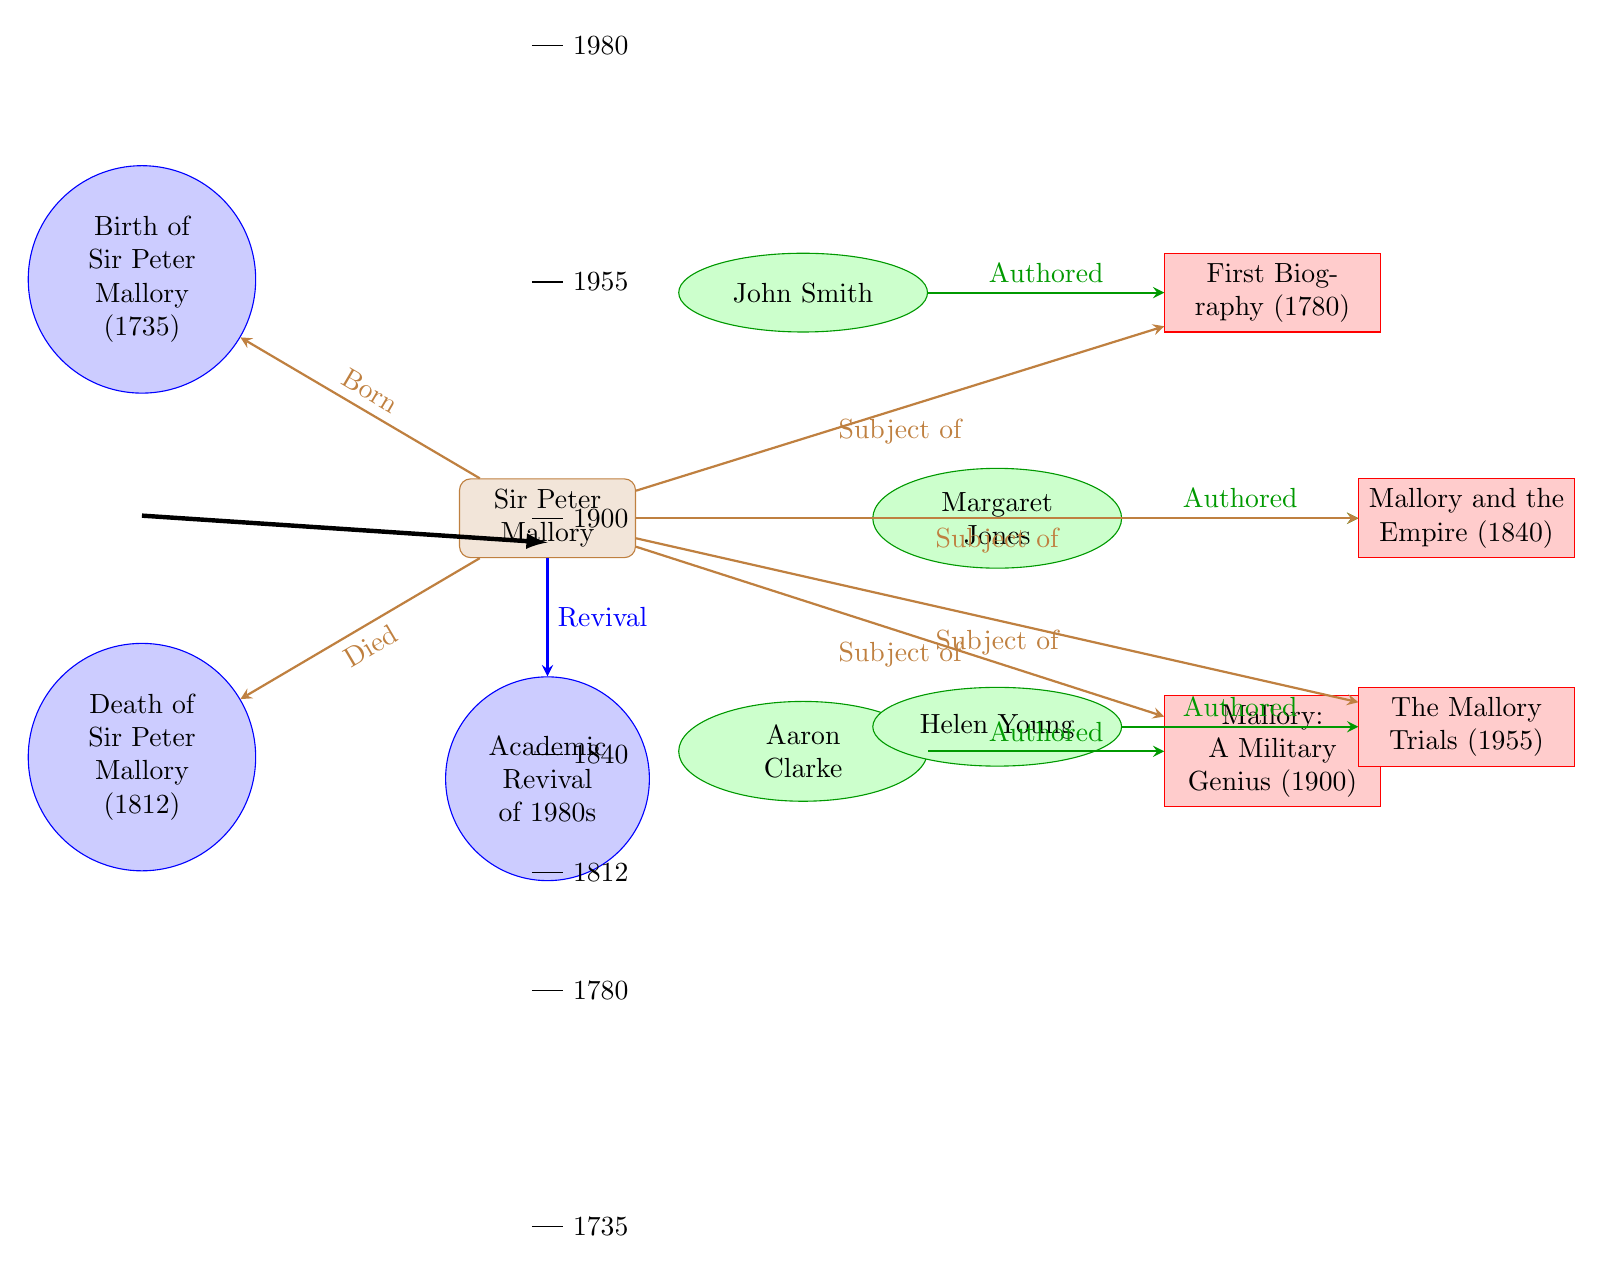What year was Sir Peter Mallory born? The diagram states that Sir Peter Mallory was born in 1735, which is indicated close to the node labeled "Birth of Sir Peter Mallory."
Answer: 1735 What event marks the death of Sir Peter Mallory? The node labeled "Death of Sir Peter Mallory (1812)" specifies the event that marks his death, which happened in 1812.
Answer: 1812 Who authored the first biography of Sir Peter Mallory? The diagram shows a connection from John Smith to the publication "First Biography (1780)," indicating that John Smith was the author of this biography.
Answer: John Smith Which publication discusses Mallory's military prowess? The publication labeled "Mallory: A Military Genius (1900)" is connected to Aaron Clarke, signifying that this work discusses Mallory's military contributions.
Answer: Mallory: A Military Genius (1900) What significant event occurred in the 1980s regarding Sir Peter Mallory? The diagram notes an "Academic Revival of 1980s," connected to Mallory, indicating that this was a significant event related to his legacy.
Answer: Academic Revival of 1980s Which publication occurred the earliest in the timeline? By examining the years associated with each publication in the timeline, the earliest publication is the "First Biography (1780)," which corresponds to 1780.
Answer: First Biography (1780) How many authors are mentioned in connection with Sir Peter Mallory? The diagram features four authors: John Smith, Margaret Jones, Aaron Clarke, and Helen Young, indicating a total count of four authors.
Answer: 4 What publication relates to the trials of Sir Peter Mallory? The publication titled "The Mallory Trials (1955)" is referenced in the diagram under Helen Young, indicating that it relates to the trials associated with Mallory.
Answer: The Mallory Trials (1955) Which historical event is indicated to have a connection with Mallory in the 1980s? The node labeled "Academic Revival of 1980s" connects to Sir Peter Mallory, indicating that this event is associated with him during that time period.
Answer: Academic Revival of 1980s 